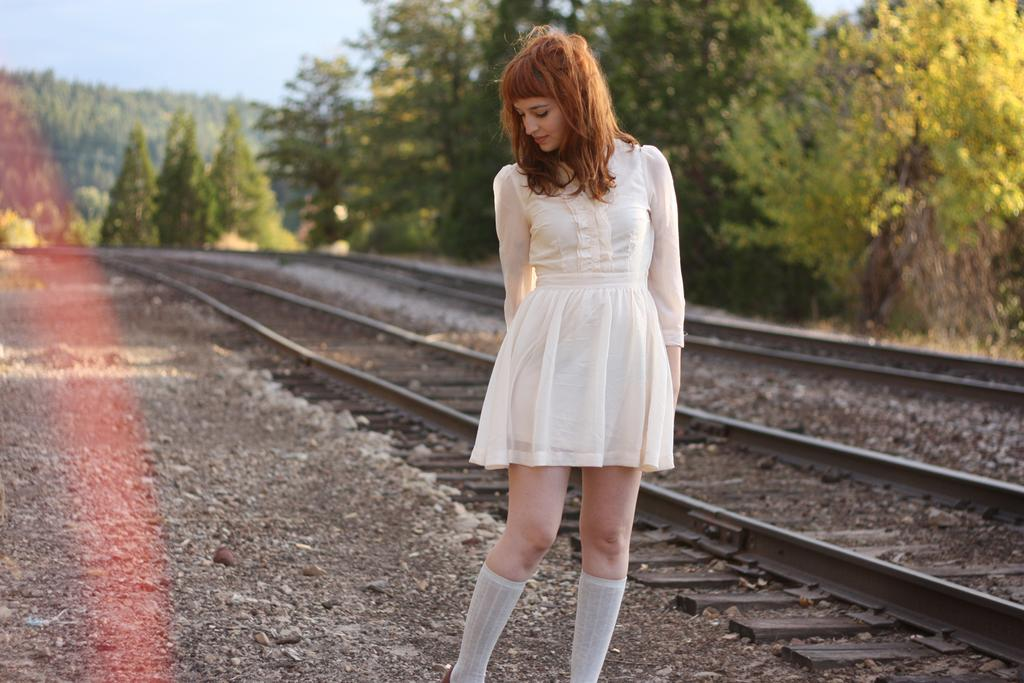Who is the main subject in the image? There is a woman standing in the front of the image. What can be seen in the background of the image? There are railway tracks and trees in the background of the image. What is on the ground in the image? There are stones on the ground in the image. What type of creature is biting the woman's leg in the image? There is no creature present in the image, and the woman's leg is not being bitten. 